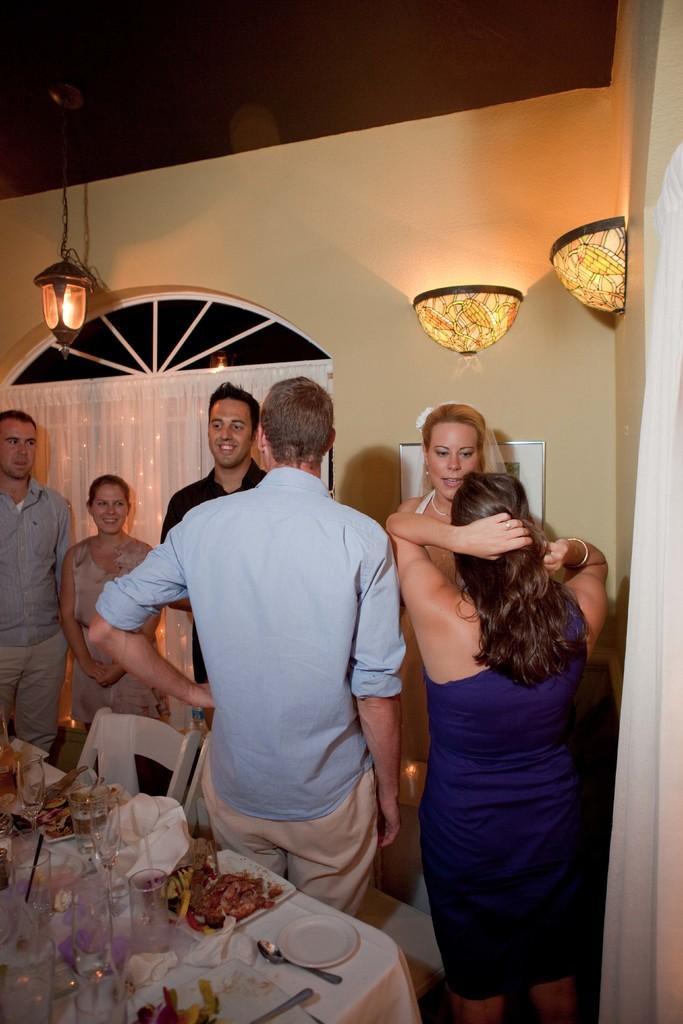How would you summarize this image in a sentence or two? In this picture, we can see a few people on the ground, we can see some objects on the ground, like chairs, table covered with cloth, and some objects on the table like, plates, spoons, glasses, food items served in a plate, and we can see the wall with window, lights, and some objects attached to it, we can see the roof. 